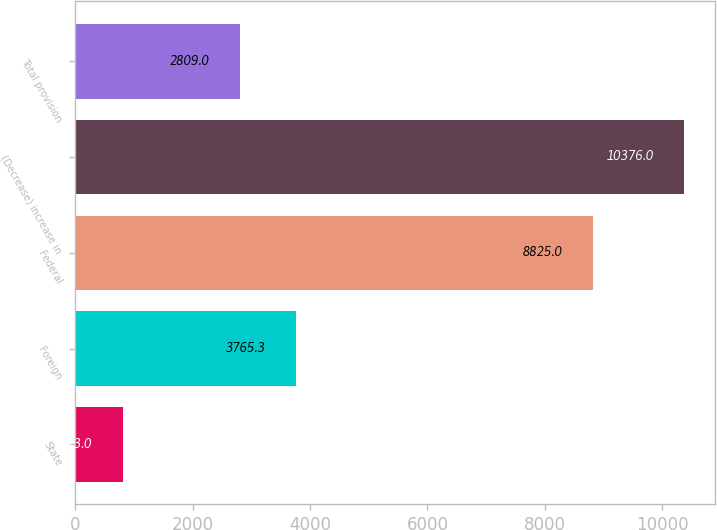Convert chart to OTSL. <chart><loc_0><loc_0><loc_500><loc_500><bar_chart><fcel>State<fcel>Foreign<fcel>Federal<fcel>(Decrease) increase in<fcel>Total provision<nl><fcel>813<fcel>3765.3<fcel>8825<fcel>10376<fcel>2809<nl></chart> 